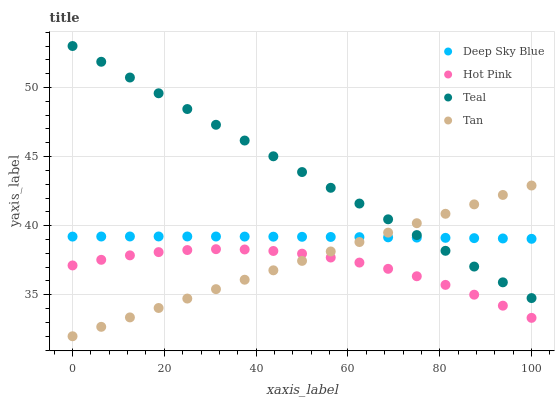Does Hot Pink have the minimum area under the curve?
Answer yes or no. Yes. Does Teal have the maximum area under the curve?
Answer yes or no. Yes. Does Teal have the minimum area under the curve?
Answer yes or no. No. Does Hot Pink have the maximum area under the curve?
Answer yes or no. No. Is Tan the smoothest?
Answer yes or no. Yes. Is Hot Pink the roughest?
Answer yes or no. Yes. Is Teal the smoothest?
Answer yes or no. No. Is Teal the roughest?
Answer yes or no. No. Does Tan have the lowest value?
Answer yes or no. Yes. Does Hot Pink have the lowest value?
Answer yes or no. No. Does Teal have the highest value?
Answer yes or no. Yes. Does Hot Pink have the highest value?
Answer yes or no. No. Is Hot Pink less than Deep Sky Blue?
Answer yes or no. Yes. Is Deep Sky Blue greater than Hot Pink?
Answer yes or no. Yes. Does Teal intersect Tan?
Answer yes or no. Yes. Is Teal less than Tan?
Answer yes or no. No. Is Teal greater than Tan?
Answer yes or no. No. Does Hot Pink intersect Deep Sky Blue?
Answer yes or no. No. 